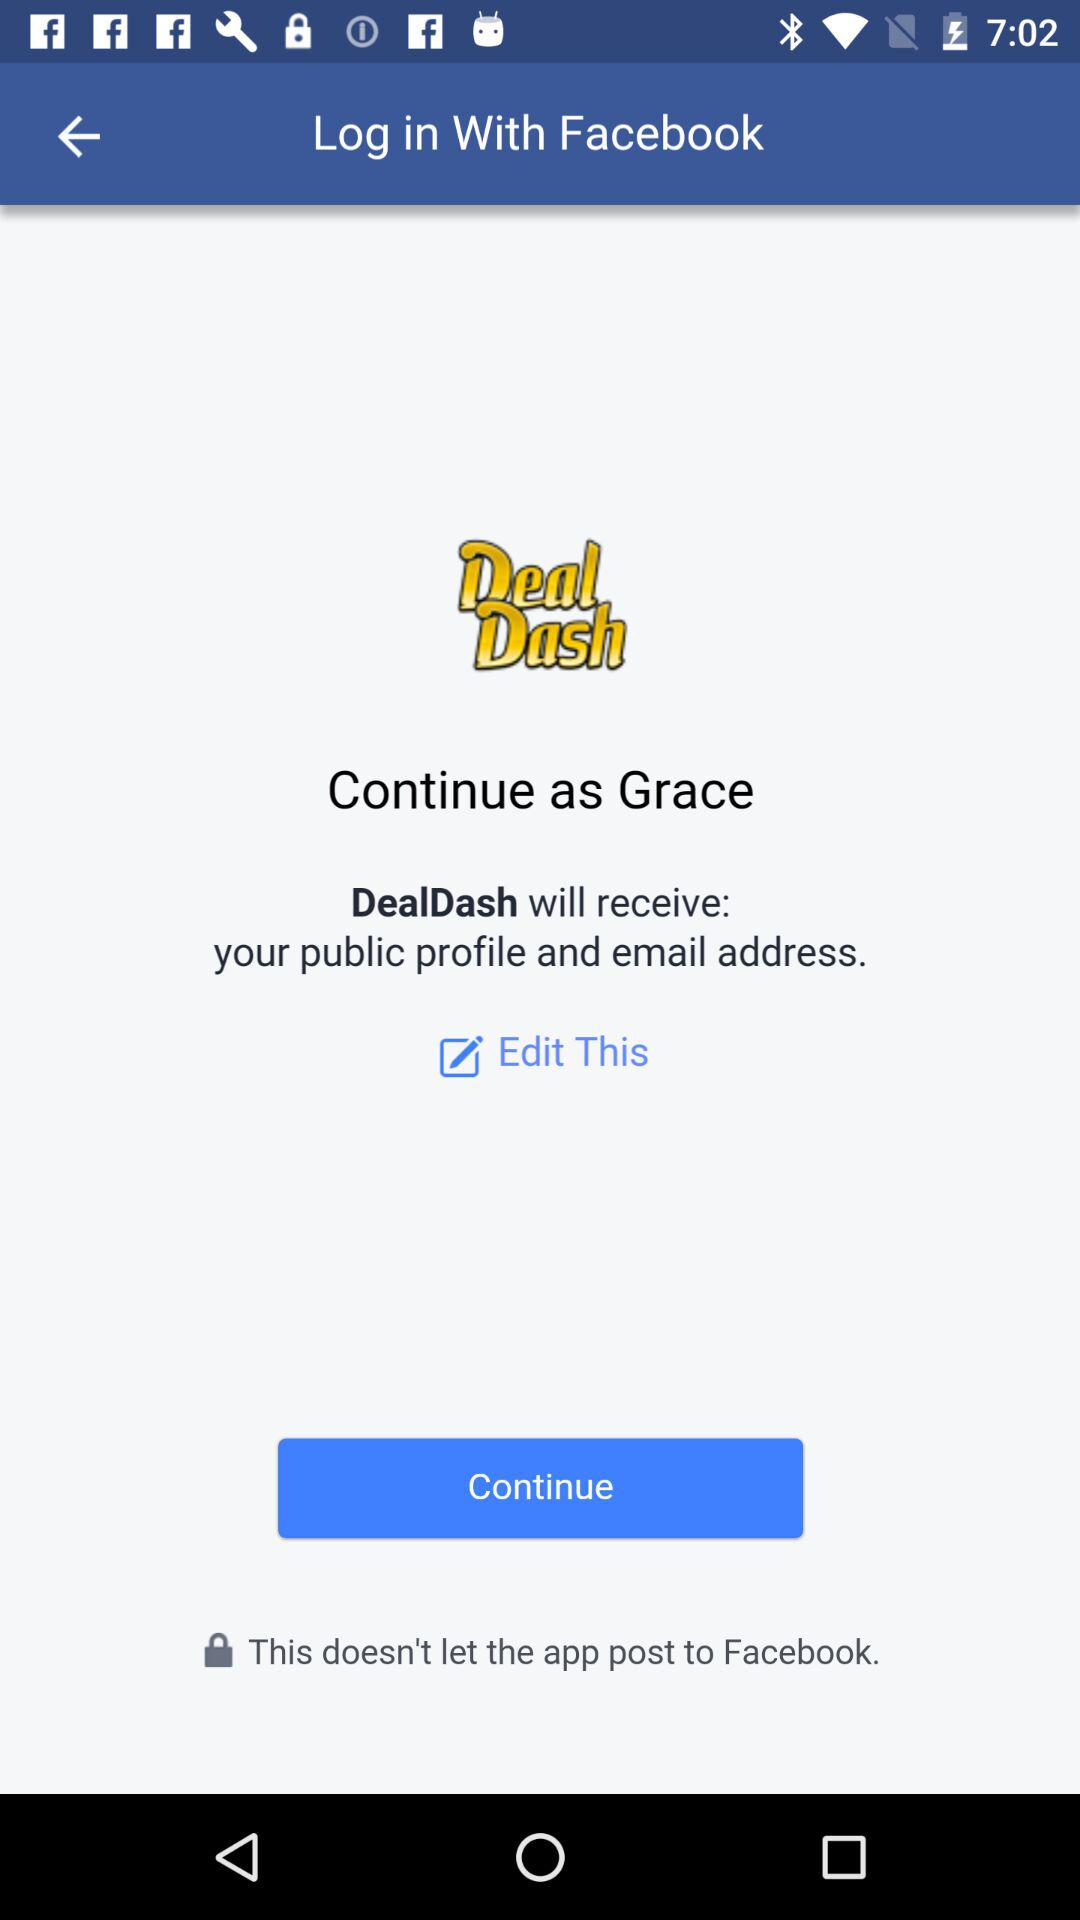What is the user name? The user name is Grace. 